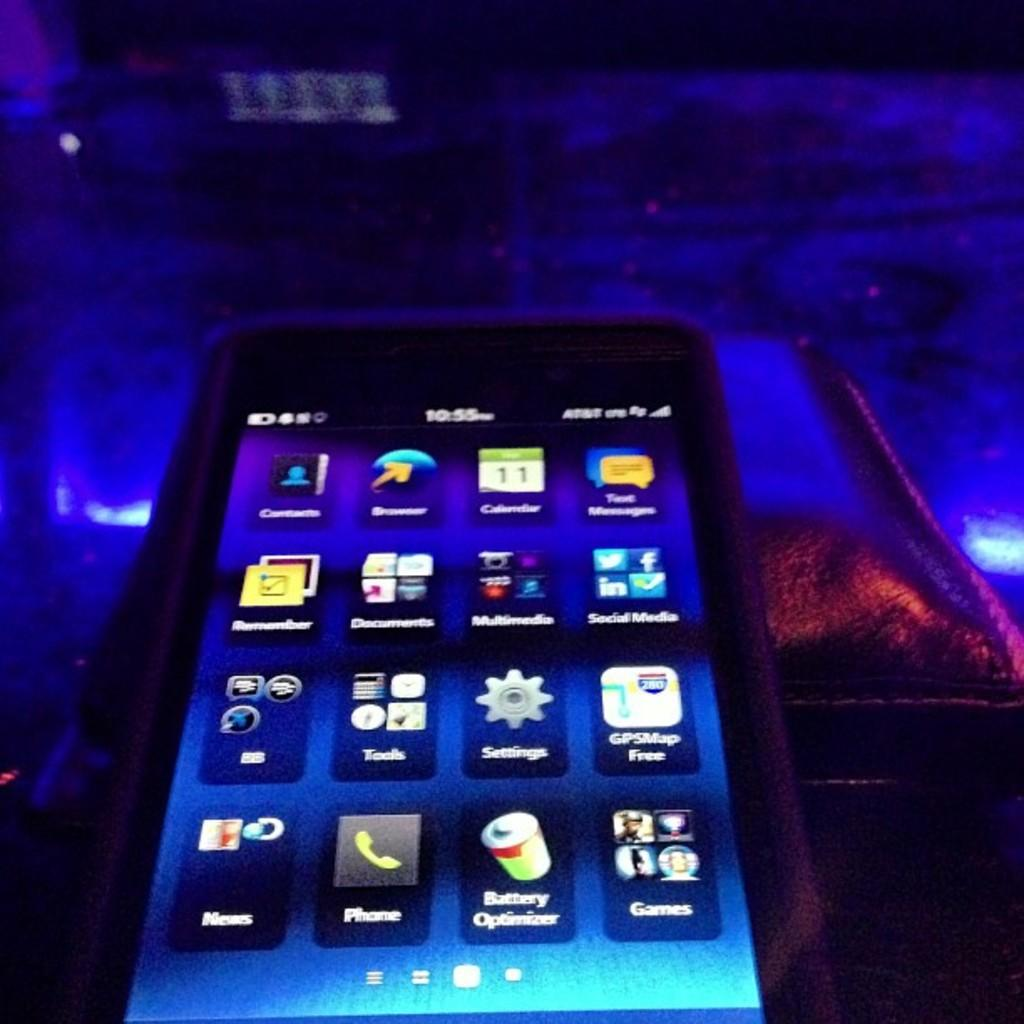What is the main object in the foreground of the image? There is a phone in the foreground of the image. How many chains are attached to the phone in the image? There are no chains attached to the phone in the image. What type of yard is visible in the background of the image? There is no yard visible in the image; it only features a phone in the foreground. 